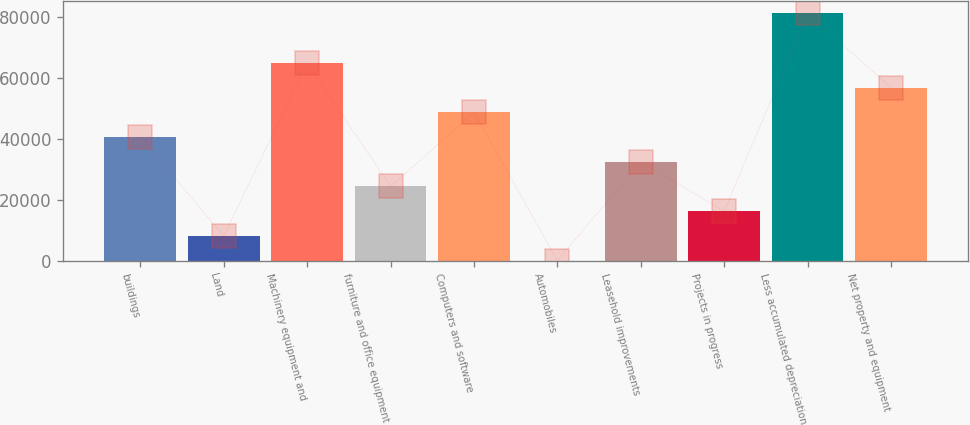Convert chart to OTSL. <chart><loc_0><loc_0><loc_500><loc_500><bar_chart><fcel>buildings<fcel>Land<fcel>Machinery equipment and<fcel>furniture and office equipment<fcel>Computers and software<fcel>Automobiles<fcel>Leasehold improvements<fcel>Projects in progress<fcel>Less accumulated depreciation<fcel>Net property and equipment<nl><fcel>40623<fcel>8135.8<fcel>64988.4<fcel>24379.4<fcel>48744.8<fcel>14<fcel>32501.2<fcel>16257.6<fcel>81232<fcel>56866.6<nl></chart> 